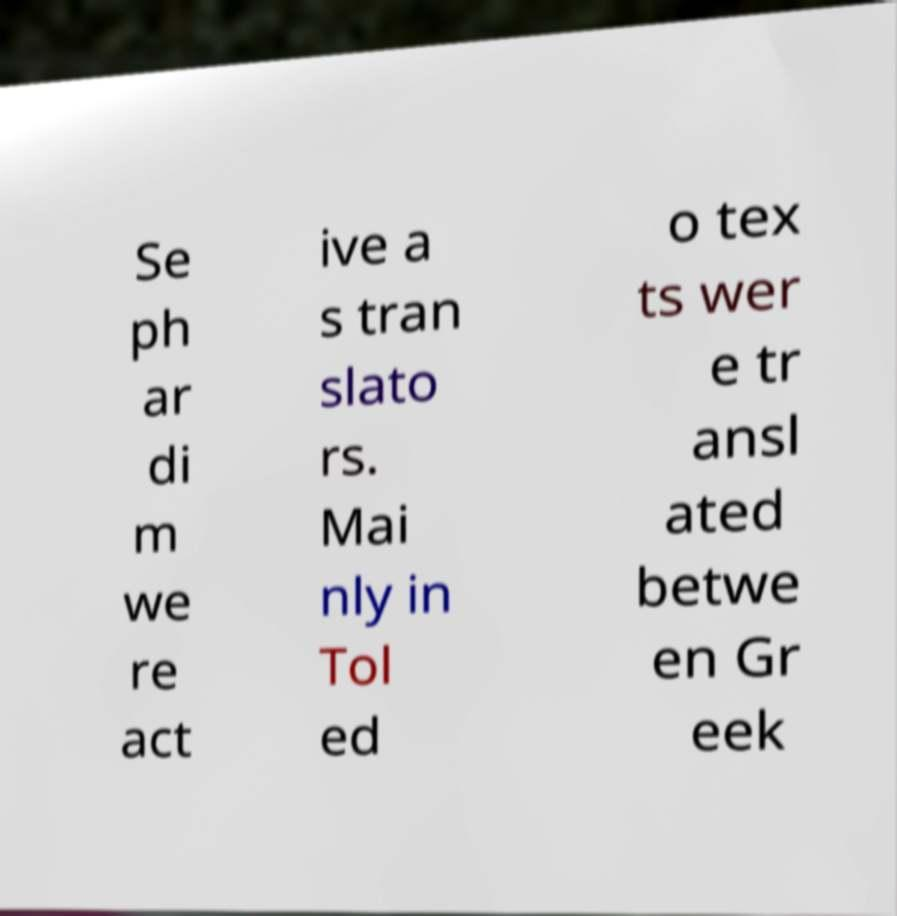Can you accurately transcribe the text from the provided image for me? Se ph ar di m we re act ive a s tran slato rs. Mai nly in Tol ed o tex ts wer e tr ansl ated betwe en Gr eek 